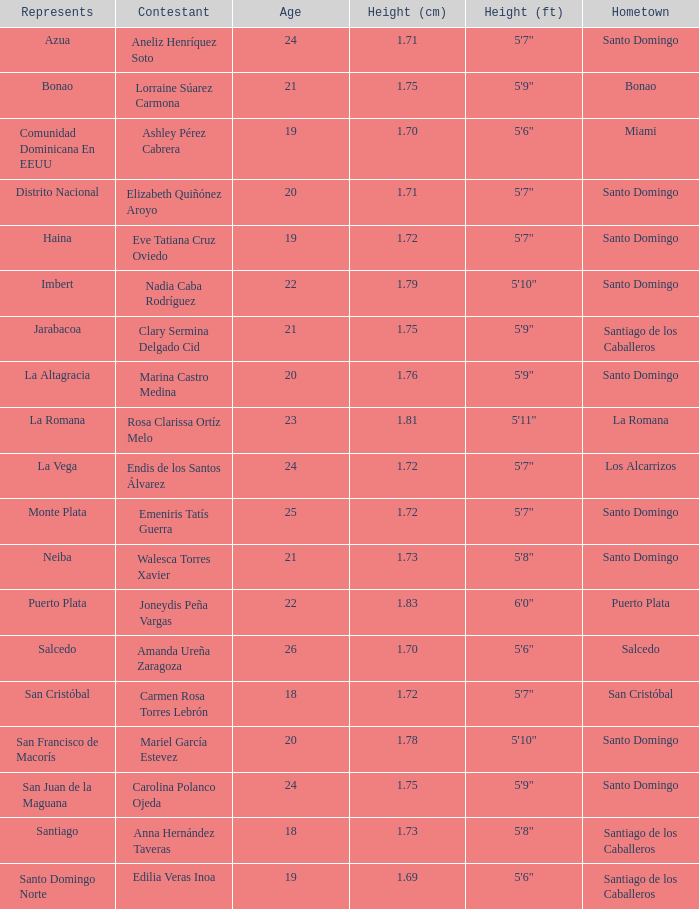Name the represents for los alcarrizos La Vega. 